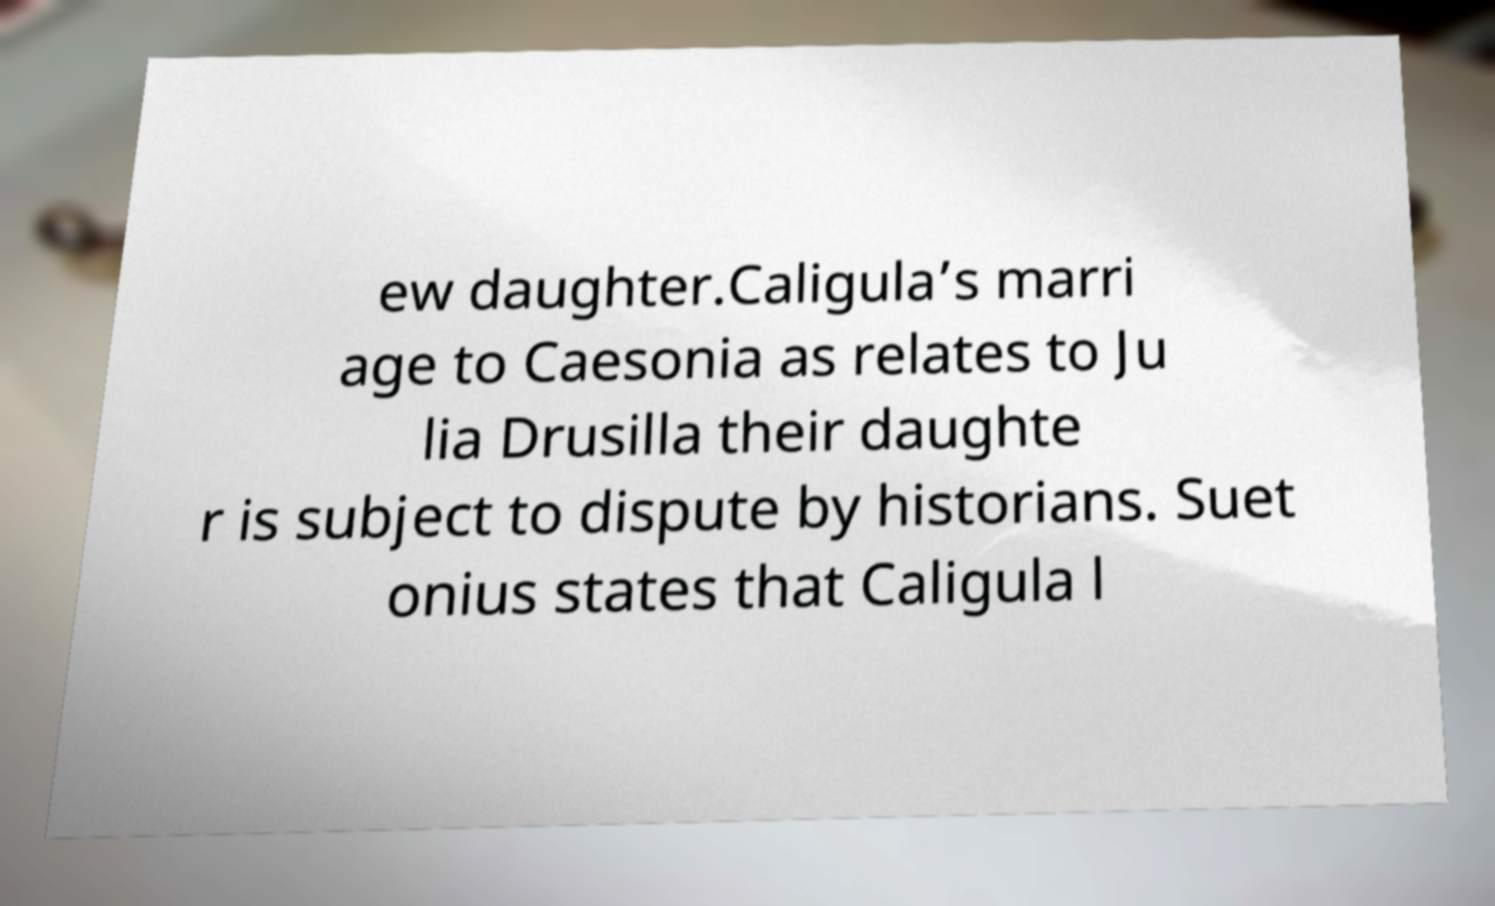Please read and relay the text visible in this image. What does it say? ew daughter.Caligula’s marri age to Caesonia as relates to Ju lia Drusilla their daughte r is subject to dispute by historians. Suet onius states that Caligula l 